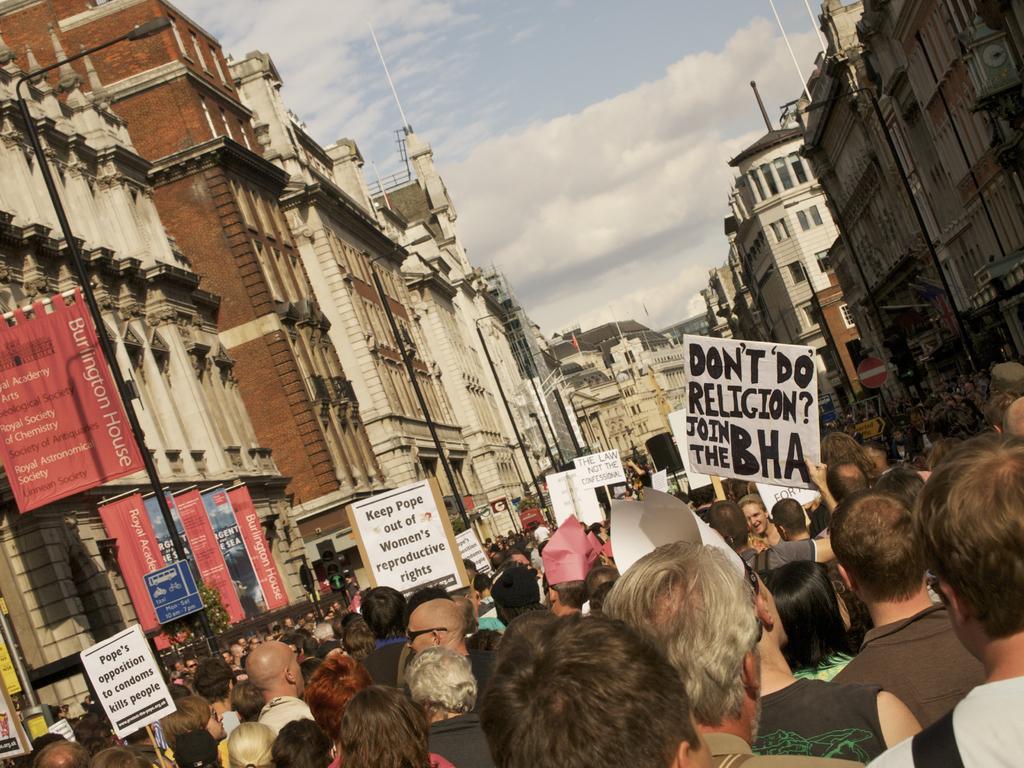How would you summarize this image in a sentence or two? In this image there are group of people standing and holding the placards, and there are poles, lights, buildings, and in the background there is sky. 